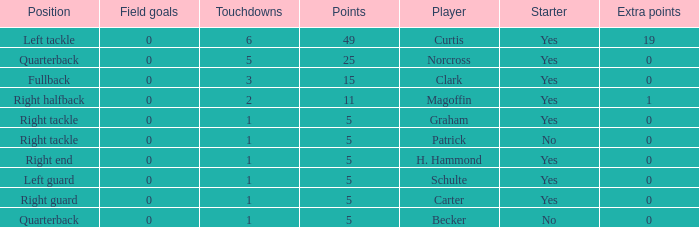Name the most field goals 0.0. 